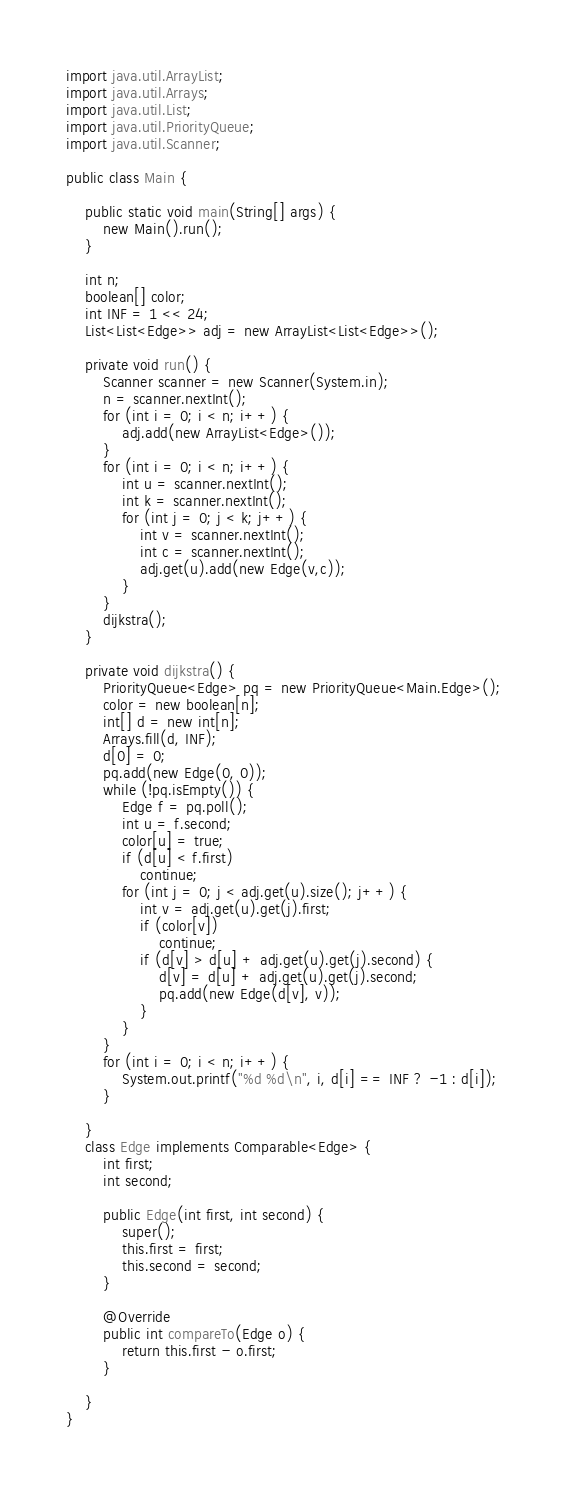<code> <loc_0><loc_0><loc_500><loc_500><_Java_>
import java.util.ArrayList;
import java.util.Arrays;
import java.util.List;
import java.util.PriorityQueue;
import java.util.Scanner;

public class Main {

	public static void main(String[] args) {
		new Main().run();
	}

	int n;
	boolean[] color;
	int INF = 1 << 24;
	List<List<Edge>> adj = new ArrayList<List<Edge>>();

	private void run() {
		Scanner scanner = new Scanner(System.in);
		n = scanner.nextInt();
		for (int i = 0; i < n; i++) {
			adj.add(new ArrayList<Edge>());
		}
		for (int i = 0; i < n; i++) {
			int u = scanner.nextInt();
			int k = scanner.nextInt();
			for (int j = 0; j < k; j++) {
				int v = scanner.nextInt();
				int c = scanner.nextInt();
				adj.get(u).add(new Edge(v,c));
			}
		}
		dijkstra();
	}

	private void dijkstra() {
		PriorityQueue<Edge> pq = new PriorityQueue<Main.Edge>();
		color = new boolean[n];
		int[] d = new int[n];
		Arrays.fill(d, INF);
		d[0] = 0;
		pq.add(new Edge(0, 0));
		while (!pq.isEmpty()) {
			Edge f = pq.poll();
			int u = f.second;
			color[u] = true;
			if (d[u] < f.first)
				continue;
			for (int j = 0; j < adj.get(u).size(); j++) {
				int v = adj.get(u).get(j).first;
				if (color[v])
					continue;
				if (d[v] > d[u] + adj.get(u).get(j).second) {
					d[v] = d[u] + adj.get(u).get(j).second;
					pq.add(new Edge(d[v], v));
				}
			}
		}
		for (int i = 0; i < n; i++) {
			System.out.printf("%d %d\n", i, d[i] == INF ? -1 : d[i]);
		}

	}
	class Edge implements Comparable<Edge> {
		int first;
		int second;

		public Edge(int first, int second) {
			super();
			this.first = first;
			this.second = second;
		}

		@Override
		public int compareTo(Edge o) {
			return this.first - o.first;
		}

	}
}</code> 